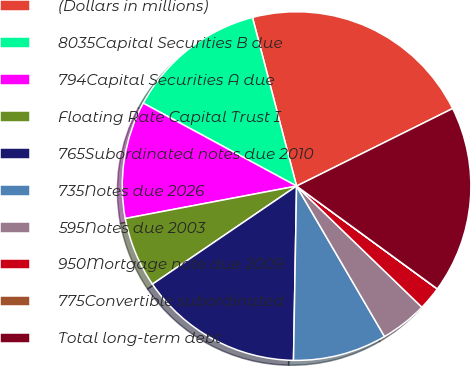<chart> <loc_0><loc_0><loc_500><loc_500><pie_chart><fcel>(Dollars in millions)<fcel>8035Capital Securities B due<fcel>794Capital Securities A due<fcel>Floating Rate Capital Trust I<fcel>765Subordinated notes due 2010<fcel>735Notes due 2026<fcel>595Notes due 2003<fcel>950Mortgage note due 2009<fcel>775Convertible subordinated<fcel>Total long-term debt<nl><fcel>21.73%<fcel>13.04%<fcel>10.87%<fcel>6.53%<fcel>15.21%<fcel>8.7%<fcel>4.35%<fcel>2.18%<fcel>0.01%<fcel>17.38%<nl></chart> 